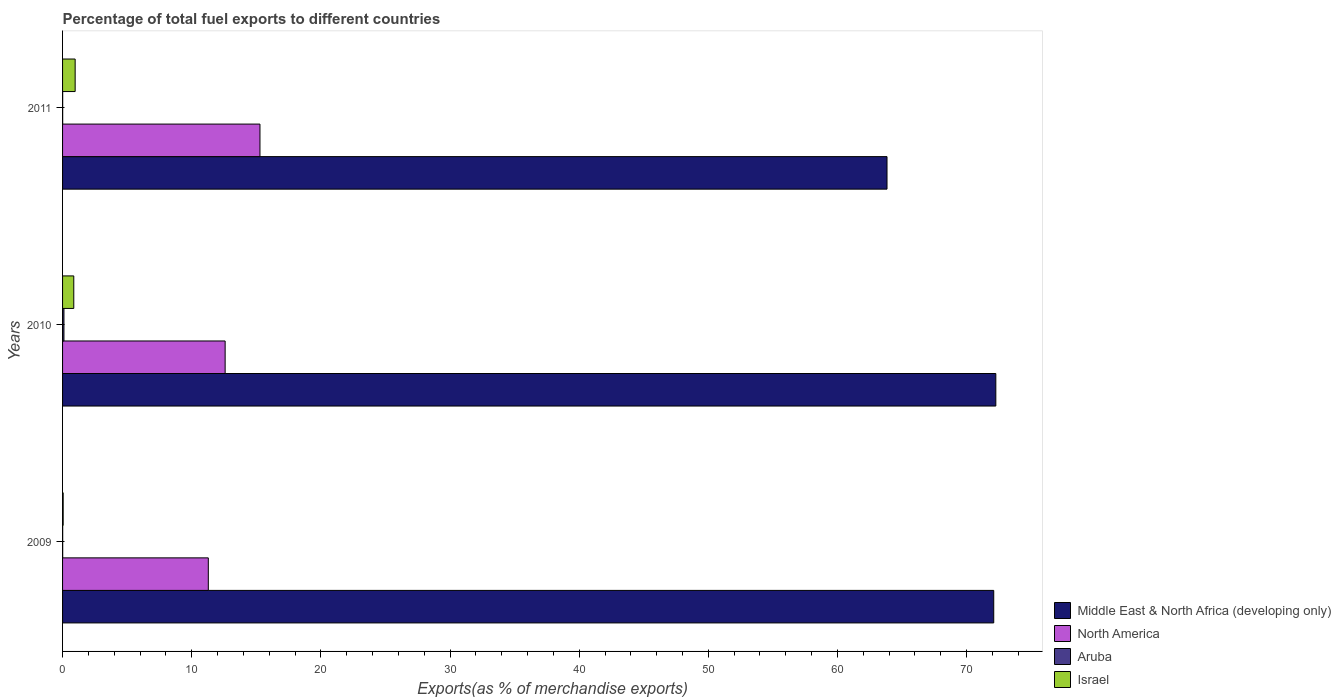How many different coloured bars are there?
Give a very brief answer. 4. How many groups of bars are there?
Offer a very short reply. 3. Are the number of bars per tick equal to the number of legend labels?
Your response must be concise. Yes. How many bars are there on the 1st tick from the bottom?
Offer a very short reply. 4. What is the percentage of exports to different countries in Israel in 2011?
Keep it short and to the point. 0.98. Across all years, what is the maximum percentage of exports to different countries in Israel?
Provide a short and direct response. 0.98. Across all years, what is the minimum percentage of exports to different countries in Aruba?
Your answer should be compact. 0.01. What is the total percentage of exports to different countries in Middle East & North Africa (developing only) in the graph?
Provide a succinct answer. 208.2. What is the difference between the percentage of exports to different countries in Aruba in 2010 and that in 2011?
Provide a short and direct response. 0.1. What is the difference between the percentage of exports to different countries in Middle East & North Africa (developing only) in 2010 and the percentage of exports to different countries in Israel in 2009?
Ensure brevity in your answer.  72.21. What is the average percentage of exports to different countries in Aruba per year?
Your answer should be very brief. 0.04. In the year 2009, what is the difference between the percentage of exports to different countries in Middle East & North Africa (developing only) and percentage of exports to different countries in Aruba?
Your answer should be very brief. 72.09. In how many years, is the percentage of exports to different countries in Israel greater than 40 %?
Make the answer very short. 0. What is the ratio of the percentage of exports to different countries in Israel in 2009 to that in 2011?
Keep it short and to the point. 0.05. Is the difference between the percentage of exports to different countries in Middle East & North Africa (developing only) in 2010 and 2011 greater than the difference between the percentage of exports to different countries in Aruba in 2010 and 2011?
Make the answer very short. Yes. What is the difference between the highest and the second highest percentage of exports to different countries in Middle East & North Africa (developing only)?
Your answer should be compact. 0.16. What is the difference between the highest and the lowest percentage of exports to different countries in Israel?
Your response must be concise. 0.93. In how many years, is the percentage of exports to different countries in Aruba greater than the average percentage of exports to different countries in Aruba taken over all years?
Provide a short and direct response. 1. Is the sum of the percentage of exports to different countries in North America in 2009 and 2010 greater than the maximum percentage of exports to different countries in Aruba across all years?
Ensure brevity in your answer.  Yes. What does the 1st bar from the top in 2010 represents?
Provide a short and direct response. Israel. How many bars are there?
Give a very brief answer. 12. Are all the bars in the graph horizontal?
Your answer should be compact. Yes. What is the difference between two consecutive major ticks on the X-axis?
Your answer should be compact. 10. What is the title of the graph?
Make the answer very short. Percentage of total fuel exports to different countries. Does "Turkmenistan" appear as one of the legend labels in the graph?
Your response must be concise. No. What is the label or title of the X-axis?
Your response must be concise. Exports(as % of merchandise exports). What is the Exports(as % of merchandise exports) in Middle East & North Africa (developing only) in 2009?
Your answer should be compact. 72.1. What is the Exports(as % of merchandise exports) of North America in 2009?
Provide a short and direct response. 11.28. What is the Exports(as % of merchandise exports) in Aruba in 2009?
Offer a very short reply. 0.01. What is the Exports(as % of merchandise exports) of Israel in 2009?
Make the answer very short. 0.05. What is the Exports(as % of merchandise exports) in Middle East & North Africa (developing only) in 2010?
Make the answer very short. 72.26. What is the Exports(as % of merchandise exports) in North America in 2010?
Provide a short and direct response. 12.59. What is the Exports(as % of merchandise exports) in Aruba in 2010?
Your answer should be very brief. 0.11. What is the Exports(as % of merchandise exports) in Israel in 2010?
Offer a very short reply. 0.87. What is the Exports(as % of merchandise exports) in Middle East & North Africa (developing only) in 2011?
Keep it short and to the point. 63.84. What is the Exports(as % of merchandise exports) in North America in 2011?
Offer a very short reply. 15.28. What is the Exports(as % of merchandise exports) of Aruba in 2011?
Offer a terse response. 0.01. What is the Exports(as % of merchandise exports) of Israel in 2011?
Provide a short and direct response. 0.98. Across all years, what is the maximum Exports(as % of merchandise exports) in Middle East & North Africa (developing only)?
Your response must be concise. 72.26. Across all years, what is the maximum Exports(as % of merchandise exports) of North America?
Your response must be concise. 15.28. Across all years, what is the maximum Exports(as % of merchandise exports) of Aruba?
Your response must be concise. 0.11. Across all years, what is the maximum Exports(as % of merchandise exports) of Israel?
Ensure brevity in your answer.  0.98. Across all years, what is the minimum Exports(as % of merchandise exports) of Middle East & North Africa (developing only)?
Make the answer very short. 63.84. Across all years, what is the minimum Exports(as % of merchandise exports) of North America?
Keep it short and to the point. 11.28. Across all years, what is the minimum Exports(as % of merchandise exports) in Aruba?
Make the answer very short. 0.01. Across all years, what is the minimum Exports(as % of merchandise exports) in Israel?
Offer a terse response. 0.05. What is the total Exports(as % of merchandise exports) in Middle East & North Africa (developing only) in the graph?
Keep it short and to the point. 208.2. What is the total Exports(as % of merchandise exports) of North America in the graph?
Ensure brevity in your answer.  39.16. What is the total Exports(as % of merchandise exports) in Aruba in the graph?
Provide a short and direct response. 0.13. What is the total Exports(as % of merchandise exports) of Israel in the graph?
Your answer should be compact. 1.89. What is the difference between the Exports(as % of merchandise exports) in Middle East & North Africa (developing only) in 2009 and that in 2010?
Ensure brevity in your answer.  -0.16. What is the difference between the Exports(as % of merchandise exports) of North America in 2009 and that in 2010?
Give a very brief answer. -1.3. What is the difference between the Exports(as % of merchandise exports) in Aruba in 2009 and that in 2010?
Give a very brief answer. -0.1. What is the difference between the Exports(as % of merchandise exports) of Israel in 2009 and that in 2010?
Make the answer very short. -0.82. What is the difference between the Exports(as % of merchandise exports) in Middle East & North Africa (developing only) in 2009 and that in 2011?
Make the answer very short. 8.26. What is the difference between the Exports(as % of merchandise exports) of North America in 2009 and that in 2011?
Offer a terse response. -4. What is the difference between the Exports(as % of merchandise exports) of Aruba in 2009 and that in 2011?
Offer a very short reply. 0. What is the difference between the Exports(as % of merchandise exports) in Israel in 2009 and that in 2011?
Provide a short and direct response. -0.93. What is the difference between the Exports(as % of merchandise exports) in Middle East & North Africa (developing only) in 2010 and that in 2011?
Provide a succinct answer. 8.43. What is the difference between the Exports(as % of merchandise exports) in North America in 2010 and that in 2011?
Offer a very short reply. -2.7. What is the difference between the Exports(as % of merchandise exports) in Aruba in 2010 and that in 2011?
Your response must be concise. 0.1. What is the difference between the Exports(as % of merchandise exports) in Israel in 2010 and that in 2011?
Your answer should be compact. -0.11. What is the difference between the Exports(as % of merchandise exports) in Middle East & North Africa (developing only) in 2009 and the Exports(as % of merchandise exports) in North America in 2010?
Ensure brevity in your answer.  59.51. What is the difference between the Exports(as % of merchandise exports) in Middle East & North Africa (developing only) in 2009 and the Exports(as % of merchandise exports) in Aruba in 2010?
Keep it short and to the point. 71.99. What is the difference between the Exports(as % of merchandise exports) of Middle East & North Africa (developing only) in 2009 and the Exports(as % of merchandise exports) of Israel in 2010?
Your answer should be compact. 71.23. What is the difference between the Exports(as % of merchandise exports) of North America in 2009 and the Exports(as % of merchandise exports) of Aruba in 2010?
Ensure brevity in your answer.  11.18. What is the difference between the Exports(as % of merchandise exports) of North America in 2009 and the Exports(as % of merchandise exports) of Israel in 2010?
Provide a short and direct response. 10.42. What is the difference between the Exports(as % of merchandise exports) of Aruba in 2009 and the Exports(as % of merchandise exports) of Israel in 2010?
Offer a terse response. -0.86. What is the difference between the Exports(as % of merchandise exports) in Middle East & North Africa (developing only) in 2009 and the Exports(as % of merchandise exports) in North America in 2011?
Give a very brief answer. 56.82. What is the difference between the Exports(as % of merchandise exports) in Middle East & North Africa (developing only) in 2009 and the Exports(as % of merchandise exports) in Aruba in 2011?
Offer a terse response. 72.09. What is the difference between the Exports(as % of merchandise exports) in Middle East & North Africa (developing only) in 2009 and the Exports(as % of merchandise exports) in Israel in 2011?
Ensure brevity in your answer.  71.12. What is the difference between the Exports(as % of merchandise exports) in North America in 2009 and the Exports(as % of merchandise exports) in Aruba in 2011?
Keep it short and to the point. 11.28. What is the difference between the Exports(as % of merchandise exports) in North America in 2009 and the Exports(as % of merchandise exports) in Israel in 2011?
Offer a terse response. 10.31. What is the difference between the Exports(as % of merchandise exports) in Aruba in 2009 and the Exports(as % of merchandise exports) in Israel in 2011?
Offer a very short reply. -0.97. What is the difference between the Exports(as % of merchandise exports) in Middle East & North Africa (developing only) in 2010 and the Exports(as % of merchandise exports) in North America in 2011?
Offer a terse response. 56.98. What is the difference between the Exports(as % of merchandise exports) of Middle East & North Africa (developing only) in 2010 and the Exports(as % of merchandise exports) of Aruba in 2011?
Your response must be concise. 72.25. What is the difference between the Exports(as % of merchandise exports) of Middle East & North Africa (developing only) in 2010 and the Exports(as % of merchandise exports) of Israel in 2011?
Your answer should be compact. 71.29. What is the difference between the Exports(as % of merchandise exports) in North America in 2010 and the Exports(as % of merchandise exports) in Aruba in 2011?
Your answer should be compact. 12.58. What is the difference between the Exports(as % of merchandise exports) in North America in 2010 and the Exports(as % of merchandise exports) in Israel in 2011?
Your answer should be very brief. 11.61. What is the difference between the Exports(as % of merchandise exports) of Aruba in 2010 and the Exports(as % of merchandise exports) of Israel in 2011?
Ensure brevity in your answer.  -0.87. What is the average Exports(as % of merchandise exports) in Middle East & North Africa (developing only) per year?
Offer a very short reply. 69.4. What is the average Exports(as % of merchandise exports) of North America per year?
Offer a very short reply. 13.05. What is the average Exports(as % of merchandise exports) of Aruba per year?
Offer a terse response. 0.04. What is the average Exports(as % of merchandise exports) of Israel per year?
Your answer should be very brief. 0.63. In the year 2009, what is the difference between the Exports(as % of merchandise exports) of Middle East & North Africa (developing only) and Exports(as % of merchandise exports) of North America?
Offer a very short reply. 60.81. In the year 2009, what is the difference between the Exports(as % of merchandise exports) of Middle East & North Africa (developing only) and Exports(as % of merchandise exports) of Aruba?
Ensure brevity in your answer.  72.09. In the year 2009, what is the difference between the Exports(as % of merchandise exports) of Middle East & North Africa (developing only) and Exports(as % of merchandise exports) of Israel?
Your answer should be very brief. 72.05. In the year 2009, what is the difference between the Exports(as % of merchandise exports) of North America and Exports(as % of merchandise exports) of Aruba?
Keep it short and to the point. 11.28. In the year 2009, what is the difference between the Exports(as % of merchandise exports) in North America and Exports(as % of merchandise exports) in Israel?
Your answer should be very brief. 11.24. In the year 2009, what is the difference between the Exports(as % of merchandise exports) of Aruba and Exports(as % of merchandise exports) of Israel?
Provide a succinct answer. -0.04. In the year 2010, what is the difference between the Exports(as % of merchandise exports) in Middle East & North Africa (developing only) and Exports(as % of merchandise exports) in North America?
Offer a very short reply. 59.67. In the year 2010, what is the difference between the Exports(as % of merchandise exports) in Middle East & North Africa (developing only) and Exports(as % of merchandise exports) in Aruba?
Ensure brevity in your answer.  72.15. In the year 2010, what is the difference between the Exports(as % of merchandise exports) in Middle East & North Africa (developing only) and Exports(as % of merchandise exports) in Israel?
Your response must be concise. 71.39. In the year 2010, what is the difference between the Exports(as % of merchandise exports) of North America and Exports(as % of merchandise exports) of Aruba?
Give a very brief answer. 12.48. In the year 2010, what is the difference between the Exports(as % of merchandise exports) of North America and Exports(as % of merchandise exports) of Israel?
Make the answer very short. 11.72. In the year 2010, what is the difference between the Exports(as % of merchandise exports) of Aruba and Exports(as % of merchandise exports) of Israel?
Make the answer very short. -0.76. In the year 2011, what is the difference between the Exports(as % of merchandise exports) of Middle East & North Africa (developing only) and Exports(as % of merchandise exports) of North America?
Your answer should be compact. 48.55. In the year 2011, what is the difference between the Exports(as % of merchandise exports) in Middle East & North Africa (developing only) and Exports(as % of merchandise exports) in Aruba?
Provide a short and direct response. 63.83. In the year 2011, what is the difference between the Exports(as % of merchandise exports) of Middle East & North Africa (developing only) and Exports(as % of merchandise exports) of Israel?
Your answer should be compact. 62.86. In the year 2011, what is the difference between the Exports(as % of merchandise exports) of North America and Exports(as % of merchandise exports) of Aruba?
Provide a short and direct response. 15.28. In the year 2011, what is the difference between the Exports(as % of merchandise exports) of North America and Exports(as % of merchandise exports) of Israel?
Make the answer very short. 14.31. In the year 2011, what is the difference between the Exports(as % of merchandise exports) in Aruba and Exports(as % of merchandise exports) in Israel?
Offer a very short reply. -0.97. What is the ratio of the Exports(as % of merchandise exports) of Middle East & North Africa (developing only) in 2009 to that in 2010?
Make the answer very short. 1. What is the ratio of the Exports(as % of merchandise exports) of North America in 2009 to that in 2010?
Offer a terse response. 0.9. What is the ratio of the Exports(as % of merchandise exports) of Aruba in 2009 to that in 2010?
Your answer should be compact. 0.09. What is the ratio of the Exports(as % of merchandise exports) in Israel in 2009 to that in 2010?
Provide a short and direct response. 0.05. What is the ratio of the Exports(as % of merchandise exports) of Middle East & North Africa (developing only) in 2009 to that in 2011?
Offer a very short reply. 1.13. What is the ratio of the Exports(as % of merchandise exports) of North America in 2009 to that in 2011?
Ensure brevity in your answer.  0.74. What is the ratio of the Exports(as % of merchandise exports) in Aruba in 2009 to that in 2011?
Keep it short and to the point. 1.1. What is the ratio of the Exports(as % of merchandise exports) in Israel in 2009 to that in 2011?
Offer a terse response. 0.05. What is the ratio of the Exports(as % of merchandise exports) in Middle East & North Africa (developing only) in 2010 to that in 2011?
Make the answer very short. 1.13. What is the ratio of the Exports(as % of merchandise exports) in North America in 2010 to that in 2011?
Provide a succinct answer. 0.82. What is the ratio of the Exports(as % of merchandise exports) in Aruba in 2010 to that in 2011?
Your response must be concise. 12.74. What is the ratio of the Exports(as % of merchandise exports) in Israel in 2010 to that in 2011?
Ensure brevity in your answer.  0.89. What is the difference between the highest and the second highest Exports(as % of merchandise exports) in Middle East & North Africa (developing only)?
Offer a very short reply. 0.16. What is the difference between the highest and the second highest Exports(as % of merchandise exports) in North America?
Make the answer very short. 2.7. What is the difference between the highest and the second highest Exports(as % of merchandise exports) in Aruba?
Keep it short and to the point. 0.1. What is the difference between the highest and the second highest Exports(as % of merchandise exports) of Israel?
Make the answer very short. 0.11. What is the difference between the highest and the lowest Exports(as % of merchandise exports) of Middle East & North Africa (developing only)?
Make the answer very short. 8.43. What is the difference between the highest and the lowest Exports(as % of merchandise exports) of North America?
Your answer should be very brief. 4. What is the difference between the highest and the lowest Exports(as % of merchandise exports) in Aruba?
Offer a terse response. 0.1. What is the difference between the highest and the lowest Exports(as % of merchandise exports) in Israel?
Give a very brief answer. 0.93. 